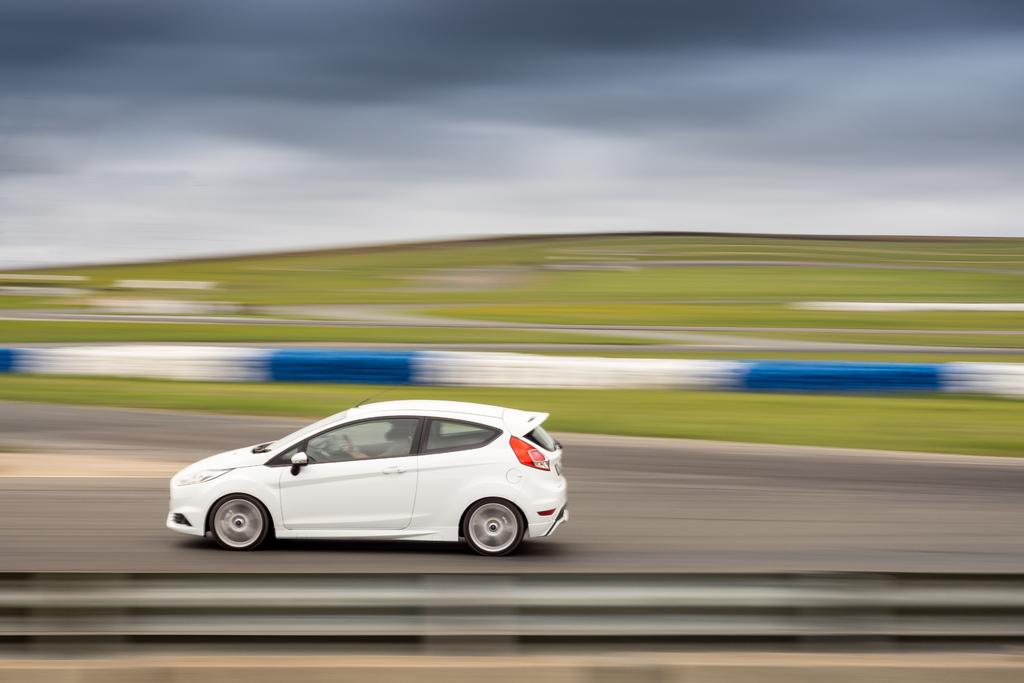What is the main subject of the image? There is a car in the image. Where is the car located? The car is on the road. What can be seen in the background of the image? There is fencing, grass, and the sky visible in the background of the image. What is the condition of the sky in the image? The sky is visible in the background of the image, and there are clouds present. How many snails can be seen crawling on the car in the image? There are no snails present in the image; it only features a car on the road. What type of servant is attending to the car in the image? There is no servant present in the image; it only features a car on the road. 